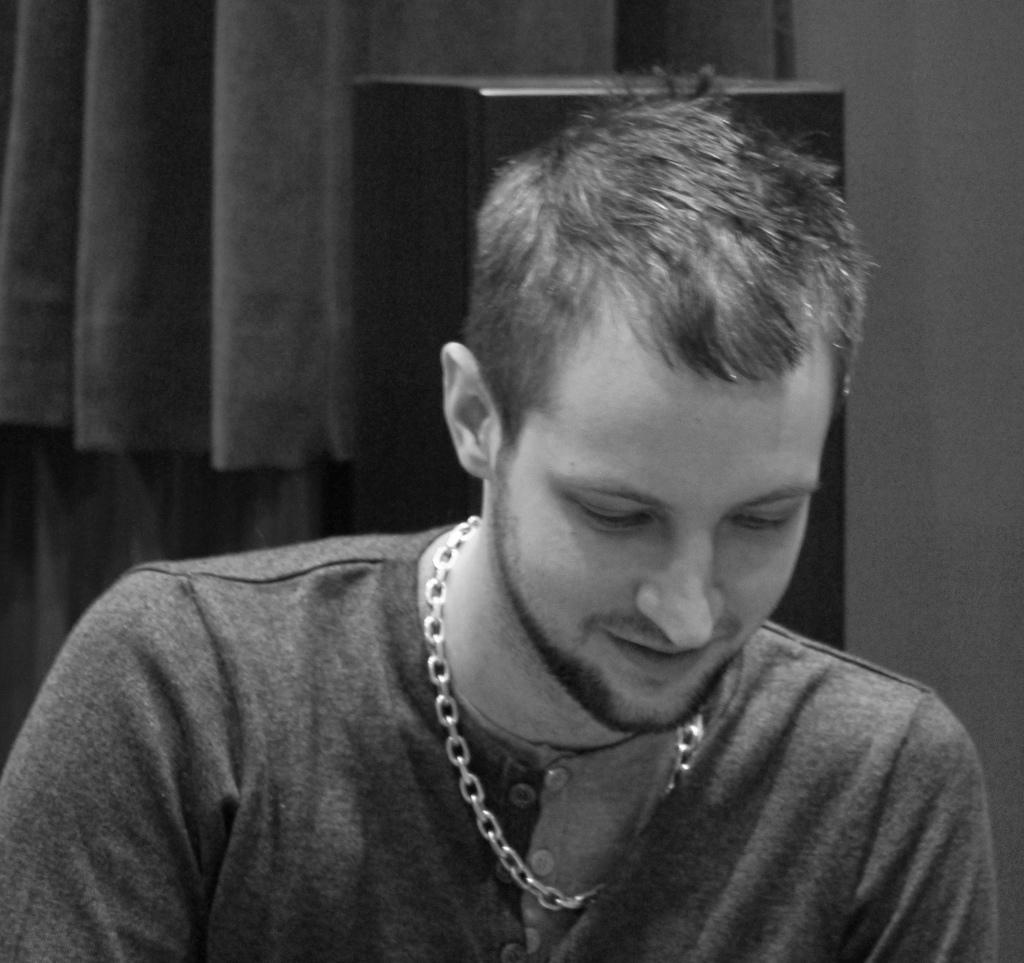What is the color scheme of the image? The image is black and white. Who or what can be seen in the image? There is a man in the image. What is visible in the background of the image? There is a wall, a curtain, and an object in the background of the image. Can you hear the man in the image crying? There is no sound in the image, so it is not possible to determine if the man is crying or not. 